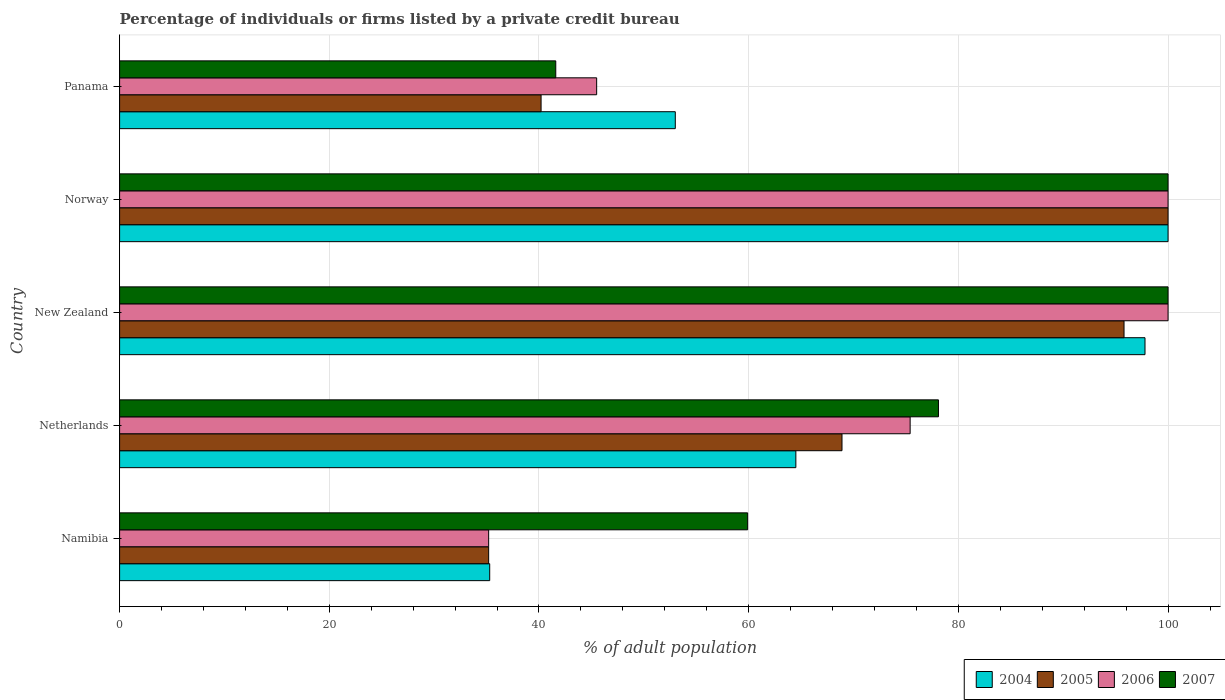How many different coloured bars are there?
Your response must be concise. 4. How many groups of bars are there?
Your answer should be compact. 5. Are the number of bars per tick equal to the number of legend labels?
Keep it short and to the point. Yes. Are the number of bars on each tick of the Y-axis equal?
Your answer should be very brief. Yes. What is the label of the 3rd group of bars from the top?
Your answer should be compact. New Zealand. In how many cases, is the number of bars for a given country not equal to the number of legend labels?
Your answer should be very brief. 0. What is the percentage of population listed by a private credit bureau in 2005 in New Zealand?
Your answer should be very brief. 95.8. Across all countries, what is the minimum percentage of population listed by a private credit bureau in 2007?
Give a very brief answer. 41.6. In which country was the percentage of population listed by a private credit bureau in 2006 maximum?
Your answer should be very brief. New Zealand. In which country was the percentage of population listed by a private credit bureau in 2004 minimum?
Offer a terse response. Namibia. What is the total percentage of population listed by a private credit bureau in 2005 in the graph?
Make the answer very short. 340.1. What is the difference between the percentage of population listed by a private credit bureau in 2005 in Netherlands and that in Panama?
Your answer should be compact. 28.7. What is the difference between the percentage of population listed by a private credit bureau in 2004 in Panama and the percentage of population listed by a private credit bureau in 2007 in Netherlands?
Make the answer very short. -25.1. What is the average percentage of population listed by a private credit bureau in 2004 per country?
Your response must be concise. 70.12. What is the difference between the percentage of population listed by a private credit bureau in 2004 and percentage of population listed by a private credit bureau in 2005 in Namibia?
Make the answer very short. 0.1. In how many countries, is the percentage of population listed by a private credit bureau in 2007 greater than 4 %?
Your answer should be very brief. 5. What is the ratio of the percentage of population listed by a private credit bureau in 2004 in Namibia to that in New Zealand?
Ensure brevity in your answer.  0.36. Is the percentage of population listed by a private credit bureau in 2004 in New Zealand less than that in Norway?
Make the answer very short. Yes. Is the difference between the percentage of population listed by a private credit bureau in 2004 in Namibia and New Zealand greater than the difference between the percentage of population listed by a private credit bureau in 2005 in Namibia and New Zealand?
Keep it short and to the point. No. What is the difference between the highest and the second highest percentage of population listed by a private credit bureau in 2007?
Provide a short and direct response. 0. What is the difference between the highest and the lowest percentage of population listed by a private credit bureau in 2005?
Ensure brevity in your answer.  64.8. Is the sum of the percentage of population listed by a private credit bureau in 2007 in Namibia and Norway greater than the maximum percentage of population listed by a private credit bureau in 2004 across all countries?
Your answer should be very brief. Yes. What does the 3rd bar from the bottom in Norway represents?
Make the answer very short. 2006. Is it the case that in every country, the sum of the percentage of population listed by a private credit bureau in 2006 and percentage of population listed by a private credit bureau in 2007 is greater than the percentage of population listed by a private credit bureau in 2004?
Keep it short and to the point. Yes. How many countries are there in the graph?
Provide a succinct answer. 5. What is the difference between two consecutive major ticks on the X-axis?
Your answer should be very brief. 20. Does the graph contain any zero values?
Give a very brief answer. No. Does the graph contain grids?
Offer a very short reply. Yes. Where does the legend appear in the graph?
Keep it short and to the point. Bottom right. How are the legend labels stacked?
Offer a terse response. Horizontal. What is the title of the graph?
Make the answer very short. Percentage of individuals or firms listed by a private credit bureau. What is the label or title of the X-axis?
Provide a short and direct response. % of adult population. What is the label or title of the Y-axis?
Your answer should be compact. Country. What is the % of adult population of 2004 in Namibia?
Your answer should be compact. 35.3. What is the % of adult population of 2005 in Namibia?
Offer a very short reply. 35.2. What is the % of adult population of 2006 in Namibia?
Provide a succinct answer. 35.2. What is the % of adult population in 2007 in Namibia?
Your answer should be very brief. 59.9. What is the % of adult population of 2004 in Netherlands?
Keep it short and to the point. 64.5. What is the % of adult population in 2005 in Netherlands?
Your answer should be very brief. 68.9. What is the % of adult population of 2006 in Netherlands?
Provide a succinct answer. 75.4. What is the % of adult population in 2007 in Netherlands?
Offer a terse response. 78.1. What is the % of adult population in 2004 in New Zealand?
Your response must be concise. 97.8. What is the % of adult population of 2005 in New Zealand?
Your response must be concise. 95.8. What is the % of adult population in 2007 in Norway?
Your response must be concise. 100. What is the % of adult population in 2004 in Panama?
Offer a very short reply. 53. What is the % of adult population of 2005 in Panama?
Provide a short and direct response. 40.2. What is the % of adult population of 2006 in Panama?
Your response must be concise. 45.5. What is the % of adult population of 2007 in Panama?
Make the answer very short. 41.6. Across all countries, what is the maximum % of adult population of 2004?
Your answer should be compact. 100. Across all countries, what is the maximum % of adult population in 2005?
Your answer should be compact. 100. Across all countries, what is the minimum % of adult population in 2004?
Offer a very short reply. 35.3. Across all countries, what is the minimum % of adult population in 2005?
Give a very brief answer. 35.2. Across all countries, what is the minimum % of adult population of 2006?
Give a very brief answer. 35.2. Across all countries, what is the minimum % of adult population of 2007?
Your answer should be compact. 41.6. What is the total % of adult population of 2004 in the graph?
Your response must be concise. 350.6. What is the total % of adult population in 2005 in the graph?
Provide a succinct answer. 340.1. What is the total % of adult population in 2006 in the graph?
Your response must be concise. 356.1. What is the total % of adult population of 2007 in the graph?
Your response must be concise. 379.6. What is the difference between the % of adult population of 2004 in Namibia and that in Netherlands?
Offer a terse response. -29.2. What is the difference between the % of adult population of 2005 in Namibia and that in Netherlands?
Provide a succinct answer. -33.7. What is the difference between the % of adult population of 2006 in Namibia and that in Netherlands?
Your answer should be compact. -40.2. What is the difference between the % of adult population in 2007 in Namibia and that in Netherlands?
Ensure brevity in your answer.  -18.2. What is the difference between the % of adult population of 2004 in Namibia and that in New Zealand?
Offer a terse response. -62.5. What is the difference between the % of adult population in 2005 in Namibia and that in New Zealand?
Offer a terse response. -60.6. What is the difference between the % of adult population in 2006 in Namibia and that in New Zealand?
Your response must be concise. -64.8. What is the difference between the % of adult population in 2007 in Namibia and that in New Zealand?
Give a very brief answer. -40.1. What is the difference between the % of adult population in 2004 in Namibia and that in Norway?
Your answer should be very brief. -64.7. What is the difference between the % of adult population of 2005 in Namibia and that in Norway?
Your response must be concise. -64.8. What is the difference between the % of adult population of 2006 in Namibia and that in Norway?
Offer a terse response. -64.8. What is the difference between the % of adult population in 2007 in Namibia and that in Norway?
Your response must be concise. -40.1. What is the difference between the % of adult population of 2004 in Namibia and that in Panama?
Offer a terse response. -17.7. What is the difference between the % of adult population in 2005 in Namibia and that in Panama?
Your answer should be compact. -5. What is the difference between the % of adult population in 2004 in Netherlands and that in New Zealand?
Give a very brief answer. -33.3. What is the difference between the % of adult population in 2005 in Netherlands and that in New Zealand?
Make the answer very short. -26.9. What is the difference between the % of adult population of 2006 in Netherlands and that in New Zealand?
Keep it short and to the point. -24.6. What is the difference between the % of adult population of 2007 in Netherlands and that in New Zealand?
Your answer should be compact. -21.9. What is the difference between the % of adult population of 2004 in Netherlands and that in Norway?
Keep it short and to the point. -35.5. What is the difference between the % of adult population of 2005 in Netherlands and that in Norway?
Keep it short and to the point. -31.1. What is the difference between the % of adult population in 2006 in Netherlands and that in Norway?
Ensure brevity in your answer.  -24.6. What is the difference between the % of adult population in 2007 in Netherlands and that in Norway?
Ensure brevity in your answer.  -21.9. What is the difference between the % of adult population in 2004 in Netherlands and that in Panama?
Offer a very short reply. 11.5. What is the difference between the % of adult population in 2005 in Netherlands and that in Panama?
Provide a short and direct response. 28.7. What is the difference between the % of adult population of 2006 in Netherlands and that in Panama?
Provide a short and direct response. 29.9. What is the difference between the % of adult population in 2007 in Netherlands and that in Panama?
Your answer should be compact. 36.5. What is the difference between the % of adult population of 2005 in New Zealand and that in Norway?
Give a very brief answer. -4.2. What is the difference between the % of adult population in 2006 in New Zealand and that in Norway?
Offer a terse response. 0. What is the difference between the % of adult population in 2004 in New Zealand and that in Panama?
Provide a succinct answer. 44.8. What is the difference between the % of adult population of 2005 in New Zealand and that in Panama?
Provide a short and direct response. 55.6. What is the difference between the % of adult population of 2006 in New Zealand and that in Panama?
Offer a terse response. 54.5. What is the difference between the % of adult population in 2007 in New Zealand and that in Panama?
Ensure brevity in your answer.  58.4. What is the difference between the % of adult population in 2005 in Norway and that in Panama?
Keep it short and to the point. 59.8. What is the difference between the % of adult population of 2006 in Norway and that in Panama?
Your answer should be compact. 54.5. What is the difference between the % of adult population in 2007 in Norway and that in Panama?
Keep it short and to the point. 58.4. What is the difference between the % of adult population in 2004 in Namibia and the % of adult population in 2005 in Netherlands?
Ensure brevity in your answer.  -33.6. What is the difference between the % of adult population of 2004 in Namibia and the % of adult population of 2006 in Netherlands?
Make the answer very short. -40.1. What is the difference between the % of adult population in 2004 in Namibia and the % of adult population in 2007 in Netherlands?
Provide a succinct answer. -42.8. What is the difference between the % of adult population in 2005 in Namibia and the % of adult population in 2006 in Netherlands?
Offer a very short reply. -40.2. What is the difference between the % of adult population in 2005 in Namibia and the % of adult population in 2007 in Netherlands?
Ensure brevity in your answer.  -42.9. What is the difference between the % of adult population in 2006 in Namibia and the % of adult population in 2007 in Netherlands?
Provide a short and direct response. -42.9. What is the difference between the % of adult population of 2004 in Namibia and the % of adult population of 2005 in New Zealand?
Provide a succinct answer. -60.5. What is the difference between the % of adult population of 2004 in Namibia and the % of adult population of 2006 in New Zealand?
Provide a succinct answer. -64.7. What is the difference between the % of adult population in 2004 in Namibia and the % of adult population in 2007 in New Zealand?
Your answer should be very brief. -64.7. What is the difference between the % of adult population of 2005 in Namibia and the % of adult population of 2006 in New Zealand?
Your answer should be very brief. -64.8. What is the difference between the % of adult population in 2005 in Namibia and the % of adult population in 2007 in New Zealand?
Ensure brevity in your answer.  -64.8. What is the difference between the % of adult population of 2006 in Namibia and the % of adult population of 2007 in New Zealand?
Provide a short and direct response. -64.8. What is the difference between the % of adult population in 2004 in Namibia and the % of adult population in 2005 in Norway?
Your response must be concise. -64.7. What is the difference between the % of adult population of 2004 in Namibia and the % of adult population of 2006 in Norway?
Keep it short and to the point. -64.7. What is the difference between the % of adult population of 2004 in Namibia and the % of adult population of 2007 in Norway?
Ensure brevity in your answer.  -64.7. What is the difference between the % of adult population of 2005 in Namibia and the % of adult population of 2006 in Norway?
Provide a succinct answer. -64.8. What is the difference between the % of adult population of 2005 in Namibia and the % of adult population of 2007 in Norway?
Offer a very short reply. -64.8. What is the difference between the % of adult population in 2006 in Namibia and the % of adult population in 2007 in Norway?
Your response must be concise. -64.8. What is the difference between the % of adult population of 2004 in Namibia and the % of adult population of 2006 in Panama?
Your answer should be very brief. -10.2. What is the difference between the % of adult population of 2005 in Namibia and the % of adult population of 2006 in Panama?
Provide a succinct answer. -10.3. What is the difference between the % of adult population of 2005 in Namibia and the % of adult population of 2007 in Panama?
Your answer should be very brief. -6.4. What is the difference between the % of adult population in 2004 in Netherlands and the % of adult population in 2005 in New Zealand?
Offer a very short reply. -31.3. What is the difference between the % of adult population of 2004 in Netherlands and the % of adult population of 2006 in New Zealand?
Provide a succinct answer. -35.5. What is the difference between the % of adult population in 2004 in Netherlands and the % of adult population in 2007 in New Zealand?
Ensure brevity in your answer.  -35.5. What is the difference between the % of adult population in 2005 in Netherlands and the % of adult population in 2006 in New Zealand?
Your answer should be very brief. -31.1. What is the difference between the % of adult population of 2005 in Netherlands and the % of adult population of 2007 in New Zealand?
Offer a very short reply. -31.1. What is the difference between the % of adult population in 2006 in Netherlands and the % of adult population in 2007 in New Zealand?
Give a very brief answer. -24.6. What is the difference between the % of adult population of 2004 in Netherlands and the % of adult population of 2005 in Norway?
Ensure brevity in your answer.  -35.5. What is the difference between the % of adult population in 2004 in Netherlands and the % of adult population in 2006 in Norway?
Your answer should be very brief. -35.5. What is the difference between the % of adult population of 2004 in Netherlands and the % of adult population of 2007 in Norway?
Make the answer very short. -35.5. What is the difference between the % of adult population of 2005 in Netherlands and the % of adult population of 2006 in Norway?
Provide a short and direct response. -31.1. What is the difference between the % of adult population in 2005 in Netherlands and the % of adult population in 2007 in Norway?
Ensure brevity in your answer.  -31.1. What is the difference between the % of adult population of 2006 in Netherlands and the % of adult population of 2007 in Norway?
Your answer should be compact. -24.6. What is the difference between the % of adult population in 2004 in Netherlands and the % of adult population in 2005 in Panama?
Your answer should be compact. 24.3. What is the difference between the % of adult population of 2004 in Netherlands and the % of adult population of 2006 in Panama?
Make the answer very short. 19. What is the difference between the % of adult population in 2004 in Netherlands and the % of adult population in 2007 in Panama?
Ensure brevity in your answer.  22.9. What is the difference between the % of adult population in 2005 in Netherlands and the % of adult population in 2006 in Panama?
Ensure brevity in your answer.  23.4. What is the difference between the % of adult population in 2005 in Netherlands and the % of adult population in 2007 in Panama?
Give a very brief answer. 27.3. What is the difference between the % of adult population in 2006 in Netherlands and the % of adult population in 2007 in Panama?
Offer a very short reply. 33.8. What is the difference between the % of adult population in 2004 in New Zealand and the % of adult population in 2006 in Norway?
Ensure brevity in your answer.  -2.2. What is the difference between the % of adult population in 2005 in New Zealand and the % of adult population in 2006 in Norway?
Ensure brevity in your answer.  -4.2. What is the difference between the % of adult population of 2005 in New Zealand and the % of adult population of 2007 in Norway?
Your response must be concise. -4.2. What is the difference between the % of adult population in 2006 in New Zealand and the % of adult population in 2007 in Norway?
Offer a terse response. 0. What is the difference between the % of adult population in 2004 in New Zealand and the % of adult population in 2005 in Panama?
Provide a succinct answer. 57.6. What is the difference between the % of adult population of 2004 in New Zealand and the % of adult population of 2006 in Panama?
Make the answer very short. 52.3. What is the difference between the % of adult population of 2004 in New Zealand and the % of adult population of 2007 in Panama?
Your answer should be very brief. 56.2. What is the difference between the % of adult population of 2005 in New Zealand and the % of adult population of 2006 in Panama?
Your answer should be very brief. 50.3. What is the difference between the % of adult population in 2005 in New Zealand and the % of adult population in 2007 in Panama?
Your answer should be very brief. 54.2. What is the difference between the % of adult population in 2006 in New Zealand and the % of adult population in 2007 in Panama?
Your answer should be compact. 58.4. What is the difference between the % of adult population of 2004 in Norway and the % of adult population of 2005 in Panama?
Make the answer very short. 59.8. What is the difference between the % of adult population of 2004 in Norway and the % of adult population of 2006 in Panama?
Keep it short and to the point. 54.5. What is the difference between the % of adult population of 2004 in Norway and the % of adult population of 2007 in Panama?
Your answer should be very brief. 58.4. What is the difference between the % of adult population of 2005 in Norway and the % of adult population of 2006 in Panama?
Offer a very short reply. 54.5. What is the difference between the % of adult population in 2005 in Norway and the % of adult population in 2007 in Panama?
Your answer should be very brief. 58.4. What is the difference between the % of adult population in 2006 in Norway and the % of adult population in 2007 in Panama?
Keep it short and to the point. 58.4. What is the average % of adult population in 2004 per country?
Your answer should be compact. 70.12. What is the average % of adult population in 2005 per country?
Your answer should be compact. 68.02. What is the average % of adult population in 2006 per country?
Your answer should be very brief. 71.22. What is the average % of adult population of 2007 per country?
Keep it short and to the point. 75.92. What is the difference between the % of adult population of 2004 and % of adult population of 2005 in Namibia?
Your answer should be compact. 0.1. What is the difference between the % of adult population in 2004 and % of adult population in 2007 in Namibia?
Keep it short and to the point. -24.6. What is the difference between the % of adult population of 2005 and % of adult population of 2007 in Namibia?
Ensure brevity in your answer.  -24.7. What is the difference between the % of adult population in 2006 and % of adult population in 2007 in Namibia?
Your answer should be compact. -24.7. What is the difference between the % of adult population of 2004 and % of adult population of 2006 in Netherlands?
Your answer should be very brief. -10.9. What is the difference between the % of adult population of 2005 and % of adult population of 2007 in Netherlands?
Offer a very short reply. -9.2. What is the difference between the % of adult population of 2006 and % of adult population of 2007 in Netherlands?
Provide a succinct answer. -2.7. What is the difference between the % of adult population of 2005 and % of adult population of 2006 in New Zealand?
Offer a terse response. -4.2. What is the difference between the % of adult population of 2005 and % of adult population of 2007 in New Zealand?
Keep it short and to the point. -4.2. What is the difference between the % of adult population of 2006 and % of adult population of 2007 in New Zealand?
Give a very brief answer. 0. What is the difference between the % of adult population in 2004 and % of adult population in 2006 in Norway?
Your response must be concise. 0. What is the difference between the % of adult population of 2004 and % of adult population of 2007 in Norway?
Offer a very short reply. 0. What is the difference between the % of adult population of 2005 and % of adult population of 2007 in Norway?
Provide a short and direct response. 0. What is the difference between the % of adult population in 2006 and % of adult population in 2007 in Norway?
Keep it short and to the point. 0. What is the difference between the % of adult population of 2006 and % of adult population of 2007 in Panama?
Offer a terse response. 3.9. What is the ratio of the % of adult population in 2004 in Namibia to that in Netherlands?
Ensure brevity in your answer.  0.55. What is the ratio of the % of adult population of 2005 in Namibia to that in Netherlands?
Provide a short and direct response. 0.51. What is the ratio of the % of adult population of 2006 in Namibia to that in Netherlands?
Provide a short and direct response. 0.47. What is the ratio of the % of adult population of 2007 in Namibia to that in Netherlands?
Make the answer very short. 0.77. What is the ratio of the % of adult population in 2004 in Namibia to that in New Zealand?
Offer a terse response. 0.36. What is the ratio of the % of adult population of 2005 in Namibia to that in New Zealand?
Provide a short and direct response. 0.37. What is the ratio of the % of adult population in 2006 in Namibia to that in New Zealand?
Offer a terse response. 0.35. What is the ratio of the % of adult population in 2007 in Namibia to that in New Zealand?
Your response must be concise. 0.6. What is the ratio of the % of adult population in 2004 in Namibia to that in Norway?
Provide a succinct answer. 0.35. What is the ratio of the % of adult population of 2005 in Namibia to that in Norway?
Offer a very short reply. 0.35. What is the ratio of the % of adult population in 2006 in Namibia to that in Norway?
Ensure brevity in your answer.  0.35. What is the ratio of the % of adult population in 2007 in Namibia to that in Norway?
Provide a short and direct response. 0.6. What is the ratio of the % of adult population of 2004 in Namibia to that in Panama?
Your response must be concise. 0.67. What is the ratio of the % of adult population of 2005 in Namibia to that in Panama?
Keep it short and to the point. 0.88. What is the ratio of the % of adult population of 2006 in Namibia to that in Panama?
Provide a short and direct response. 0.77. What is the ratio of the % of adult population of 2007 in Namibia to that in Panama?
Offer a very short reply. 1.44. What is the ratio of the % of adult population of 2004 in Netherlands to that in New Zealand?
Offer a terse response. 0.66. What is the ratio of the % of adult population in 2005 in Netherlands to that in New Zealand?
Make the answer very short. 0.72. What is the ratio of the % of adult population of 2006 in Netherlands to that in New Zealand?
Offer a terse response. 0.75. What is the ratio of the % of adult population of 2007 in Netherlands to that in New Zealand?
Your answer should be very brief. 0.78. What is the ratio of the % of adult population of 2004 in Netherlands to that in Norway?
Make the answer very short. 0.65. What is the ratio of the % of adult population in 2005 in Netherlands to that in Norway?
Offer a very short reply. 0.69. What is the ratio of the % of adult population of 2006 in Netherlands to that in Norway?
Provide a succinct answer. 0.75. What is the ratio of the % of adult population in 2007 in Netherlands to that in Norway?
Keep it short and to the point. 0.78. What is the ratio of the % of adult population in 2004 in Netherlands to that in Panama?
Ensure brevity in your answer.  1.22. What is the ratio of the % of adult population of 2005 in Netherlands to that in Panama?
Your answer should be compact. 1.71. What is the ratio of the % of adult population in 2006 in Netherlands to that in Panama?
Offer a very short reply. 1.66. What is the ratio of the % of adult population of 2007 in Netherlands to that in Panama?
Your answer should be very brief. 1.88. What is the ratio of the % of adult population in 2005 in New Zealand to that in Norway?
Your answer should be very brief. 0.96. What is the ratio of the % of adult population in 2007 in New Zealand to that in Norway?
Give a very brief answer. 1. What is the ratio of the % of adult population of 2004 in New Zealand to that in Panama?
Provide a succinct answer. 1.85. What is the ratio of the % of adult population of 2005 in New Zealand to that in Panama?
Your answer should be very brief. 2.38. What is the ratio of the % of adult population in 2006 in New Zealand to that in Panama?
Your answer should be compact. 2.2. What is the ratio of the % of adult population in 2007 in New Zealand to that in Panama?
Ensure brevity in your answer.  2.4. What is the ratio of the % of adult population in 2004 in Norway to that in Panama?
Give a very brief answer. 1.89. What is the ratio of the % of adult population in 2005 in Norway to that in Panama?
Keep it short and to the point. 2.49. What is the ratio of the % of adult population in 2006 in Norway to that in Panama?
Keep it short and to the point. 2.2. What is the ratio of the % of adult population of 2007 in Norway to that in Panama?
Ensure brevity in your answer.  2.4. What is the difference between the highest and the second highest % of adult population of 2006?
Make the answer very short. 0. What is the difference between the highest and the second highest % of adult population of 2007?
Your response must be concise. 0. What is the difference between the highest and the lowest % of adult population of 2004?
Make the answer very short. 64.7. What is the difference between the highest and the lowest % of adult population of 2005?
Keep it short and to the point. 64.8. What is the difference between the highest and the lowest % of adult population of 2006?
Give a very brief answer. 64.8. What is the difference between the highest and the lowest % of adult population in 2007?
Offer a very short reply. 58.4. 